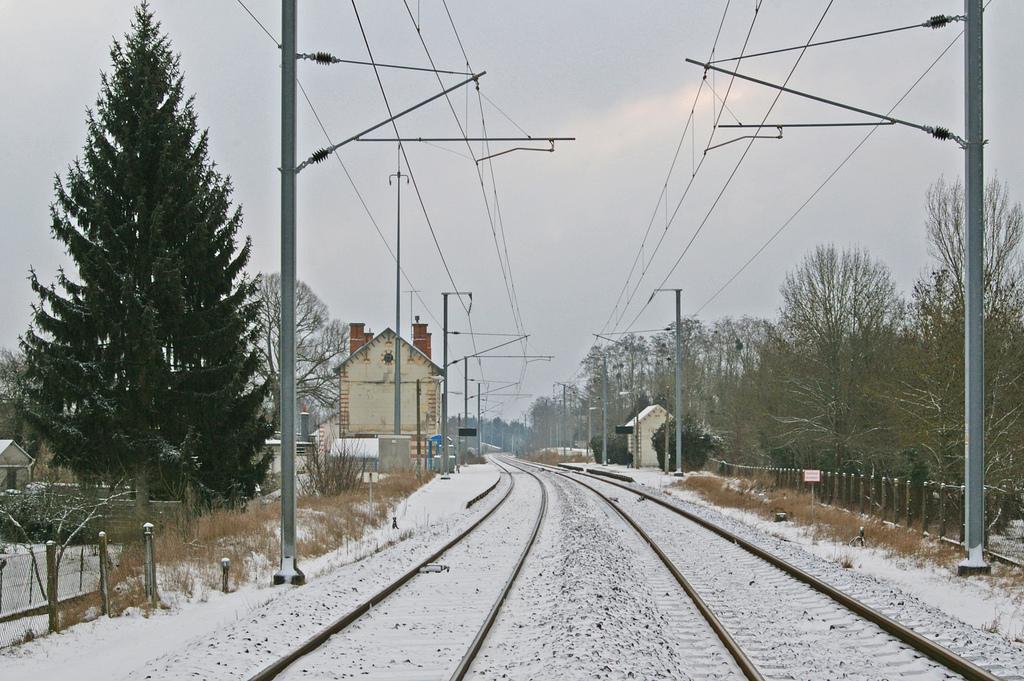How would you summarize this image in a sentence or two? In this picture we can see railway tracks, electric poles with wires on the ground, here we can see fences, sheds, trees, name board and some objects and we can see sky in the background. 